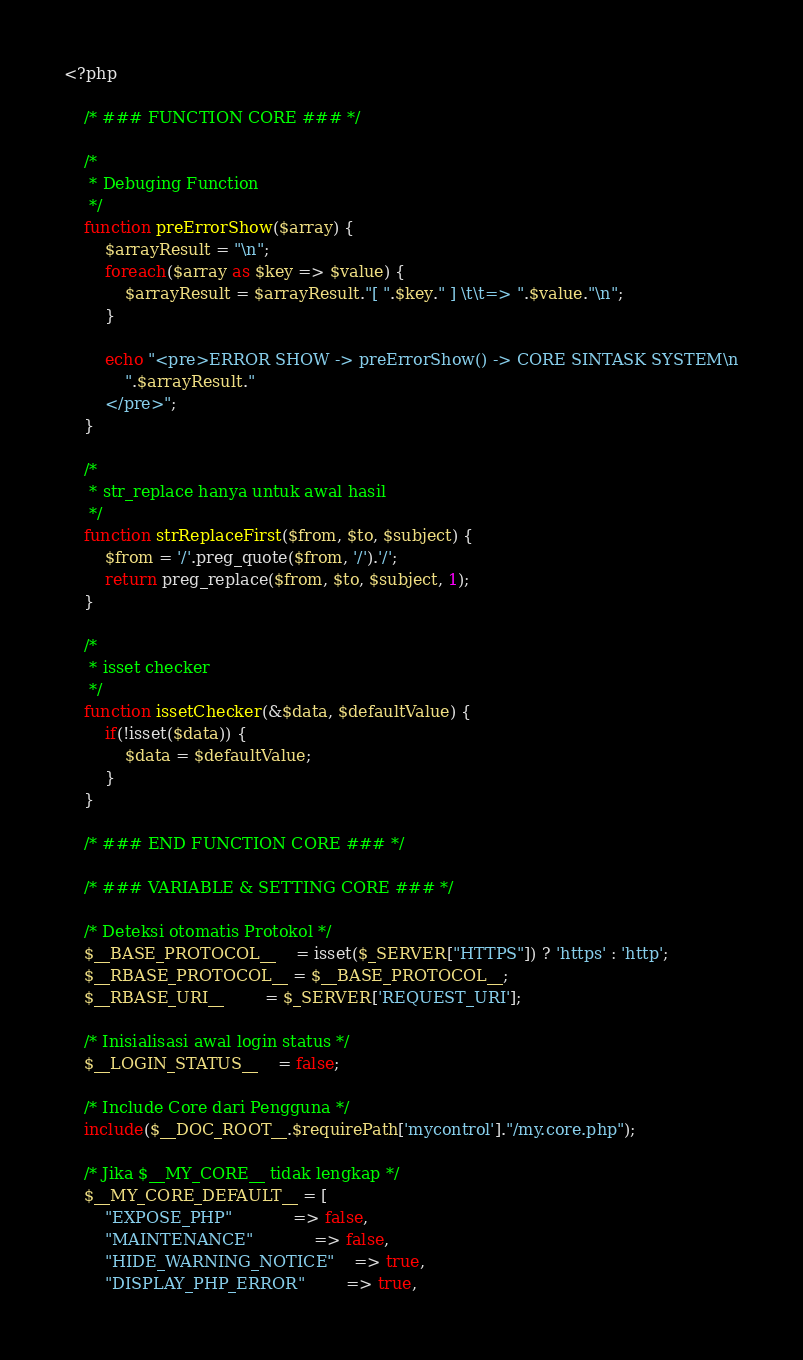Convert code to text. <code><loc_0><loc_0><loc_500><loc_500><_PHP_><?php
	
	/* ### FUNCTION CORE ### */
	
	/* 
	 * Debuging Function
	 */
	function preErrorShow($array) {
		$arrayResult = "\n";
		foreach($array as $key => $value) {
			$arrayResult = $arrayResult."[ ".$key." ] \t\t=> ".$value."\n";
		}

		echo "<pre>ERROR SHOW -> preErrorShow() -> CORE SINTASK SYSTEM\n
			".$arrayResult."
		</pre>";
	}
	
	/*
	 * str_replace hanya untuk awal hasil
	 */
	function strReplaceFirst($from, $to, $subject) {
		$from = '/'.preg_quote($from, '/').'/';
		return preg_replace($from, $to, $subject, 1);
	}

	/*
	 * isset checker
	 */
	function issetChecker(&$data, $defaultValue) {
		if(!isset($data)) {
			$data = $defaultValue;
		}
	}
	
	/* ### END FUNCTION CORE ### */
	
	/* ### VARIABLE & SETTING CORE ### */

	/* Deteksi otomatis Protokol */
	$__BASE_PROTOCOL__ 	= isset($_SERVER["HTTPS"]) ? 'https' : 'http';
	$__RBASE_PROTOCOL__ = $__BASE_PROTOCOL__;
	$__RBASE_URI__ 		= $_SERVER['REQUEST_URI'];
	
	/* Inisialisasi awal login status */
	$__LOGIN_STATUS__ 	= false;

	/* Include Core dari Pengguna */
	include($__DOC_ROOT__.$requirePath['mycontrol']."/my.core.php");

	/* Jika $__MY_CORE__ tidak lengkap */
	$__MY_CORE_DEFAULT__ = [
		"EXPOSE_PHP"			=> false,
		"MAINTENANCE"			=> false,
		"HIDE_WARNING_NOTICE" 	=> true,
		"DISPLAY_PHP_ERROR"		=> true,</code> 